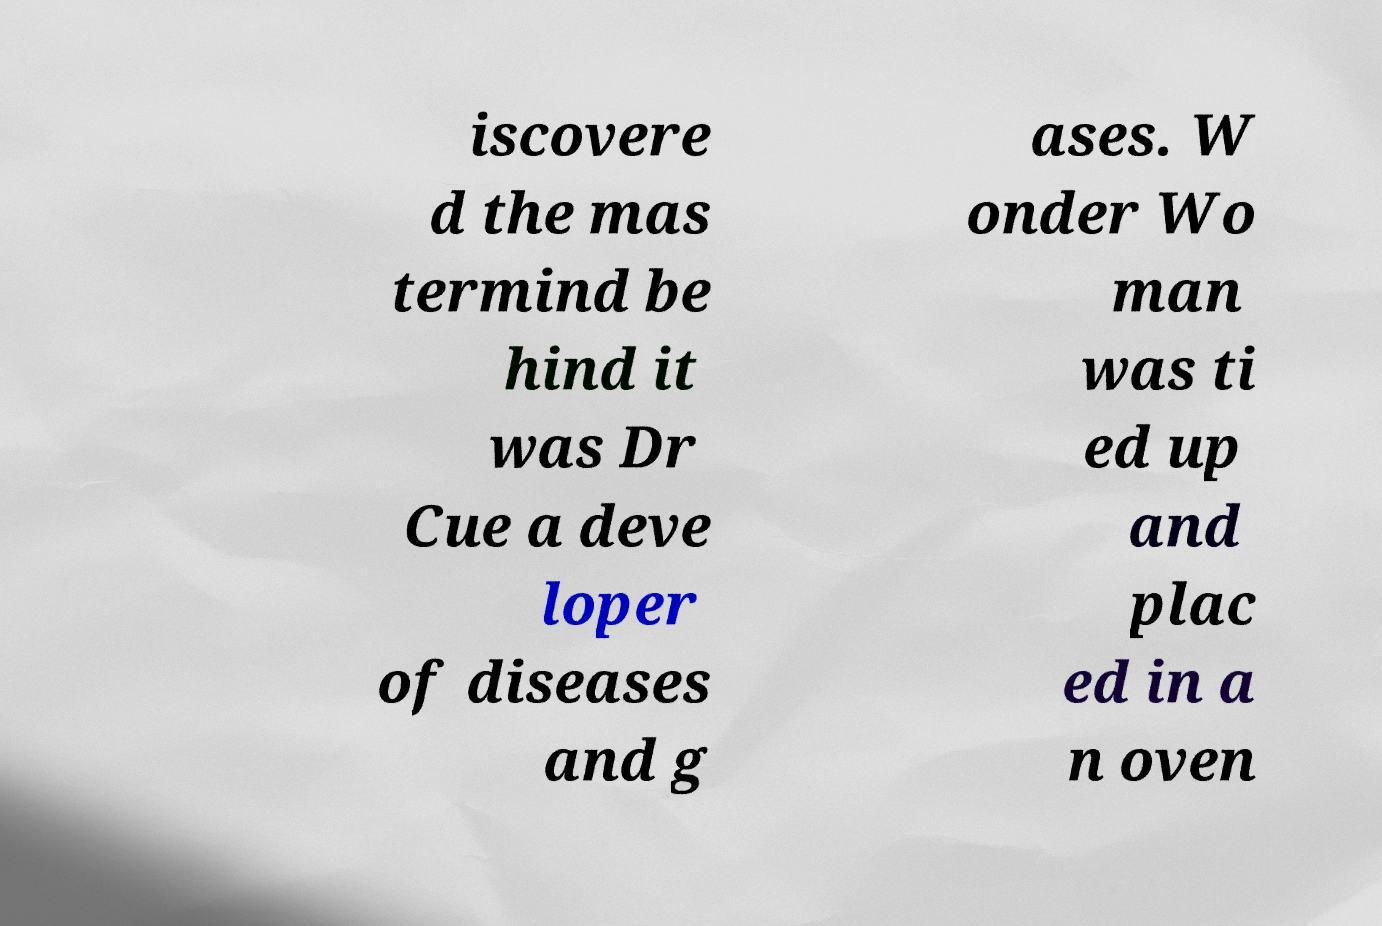Could you extract and type out the text from this image? iscovere d the mas termind be hind it was Dr Cue a deve loper of diseases and g ases. W onder Wo man was ti ed up and plac ed in a n oven 